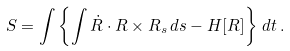Convert formula to latex. <formula><loc_0><loc_0><loc_500><loc_500>S = \int \left \{ \int \dot { R } \cdot R \times R _ { s } \, d s - H [ R ] \right \} \, d t \, .</formula> 